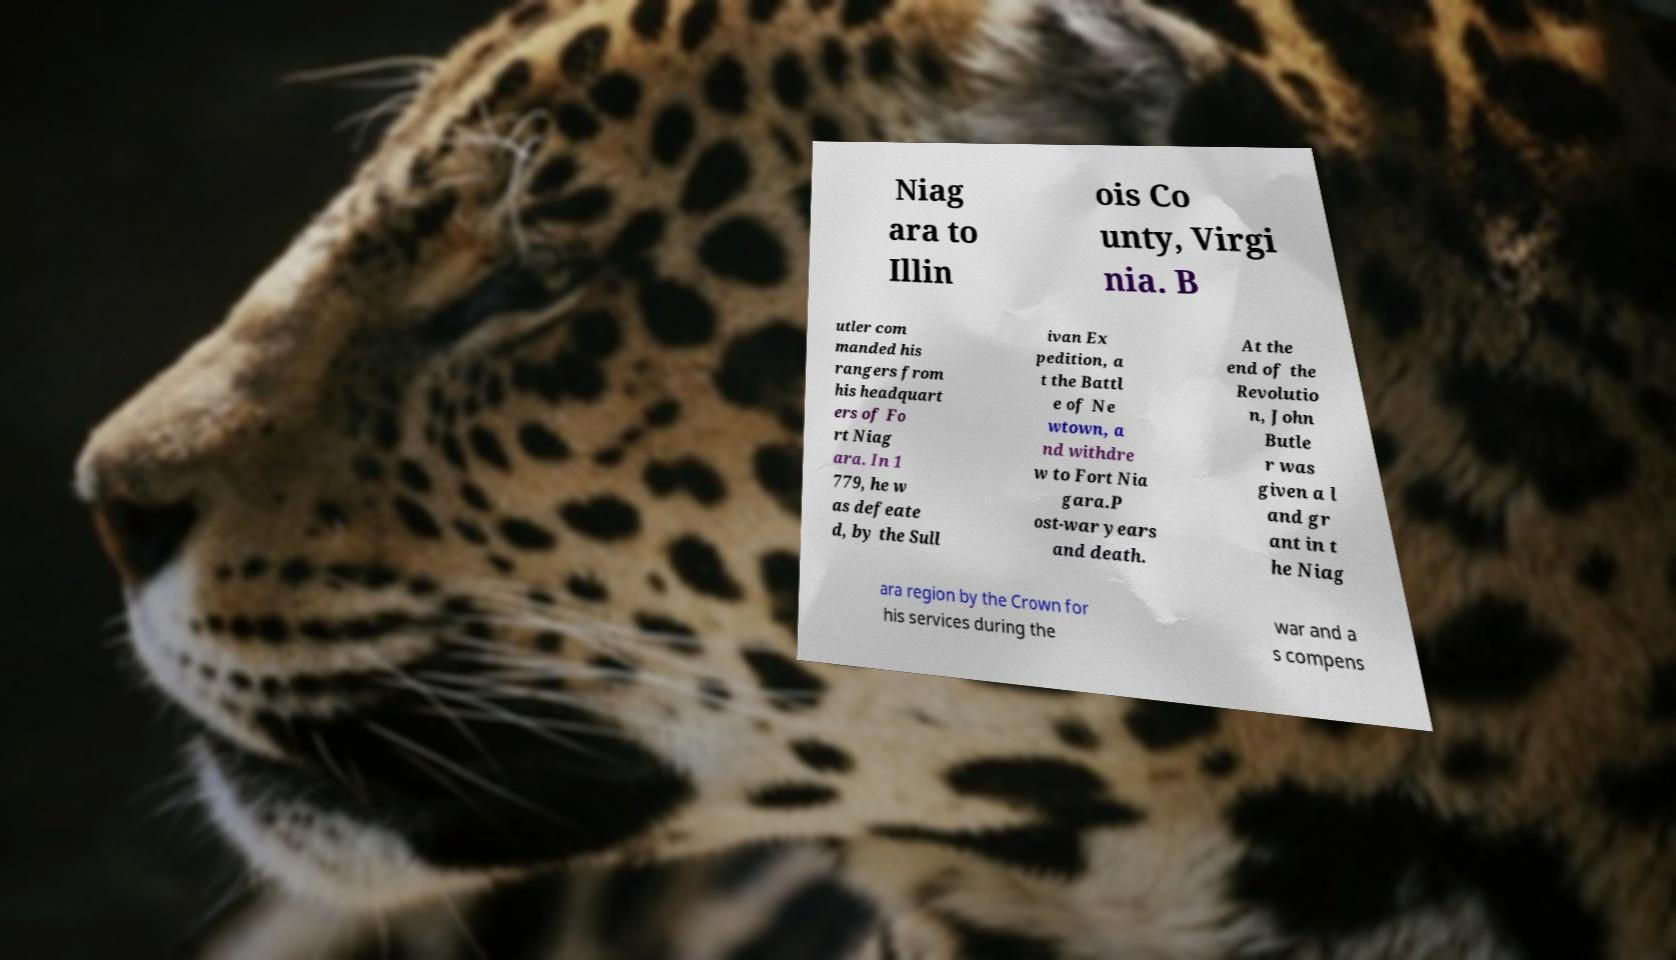Please identify and transcribe the text found in this image. Niag ara to Illin ois Co unty, Virgi nia. B utler com manded his rangers from his headquart ers of Fo rt Niag ara. In 1 779, he w as defeate d, by the Sull ivan Ex pedition, a t the Battl e of Ne wtown, a nd withdre w to Fort Nia gara.P ost-war years and death. At the end of the Revolutio n, John Butle r was given a l and gr ant in t he Niag ara region by the Crown for his services during the war and a s compens 